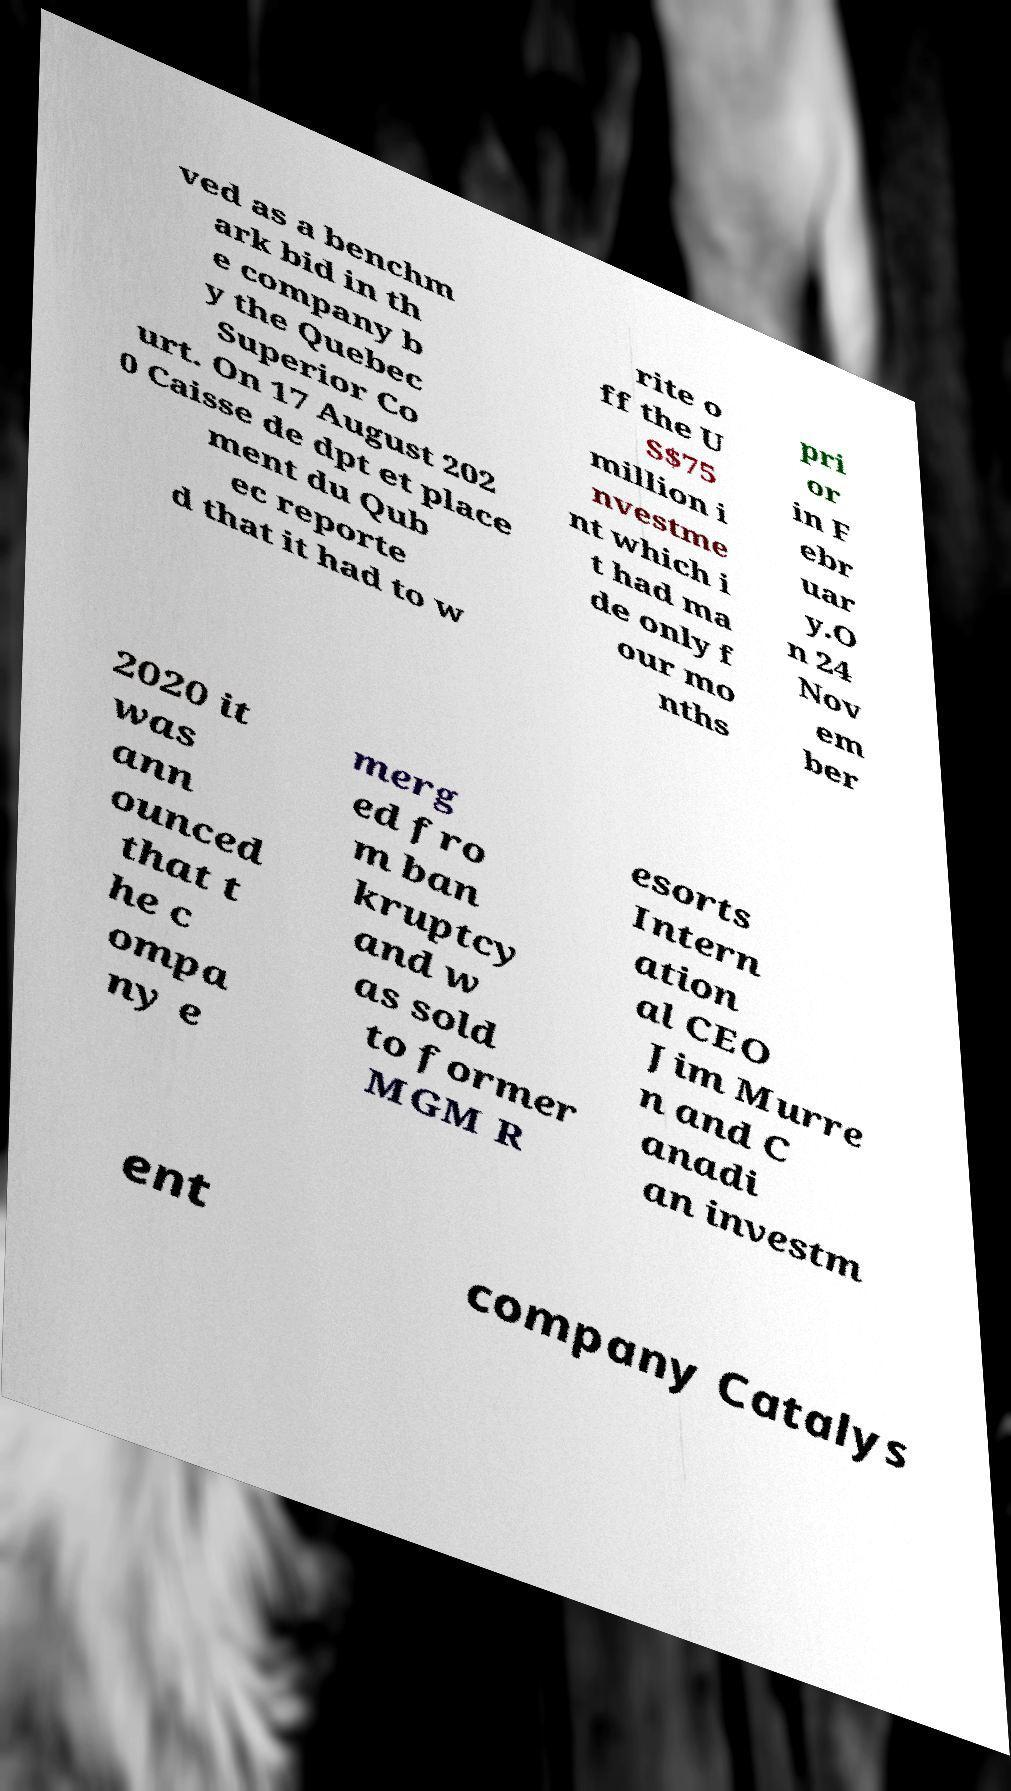There's text embedded in this image that I need extracted. Can you transcribe it verbatim? ved as a benchm ark bid in th e company b y the Quebec Superior Co urt. On 17 August 202 0 Caisse de dpt et place ment du Qub ec reporte d that it had to w rite o ff the U S$75 million i nvestme nt which i t had ma de only f our mo nths pri or in F ebr uar y.O n 24 Nov em ber 2020 it was ann ounced that t he c ompa ny e merg ed fro m ban kruptcy and w as sold to former MGM R esorts Intern ation al CEO Jim Murre n and C anadi an investm ent company Catalys 